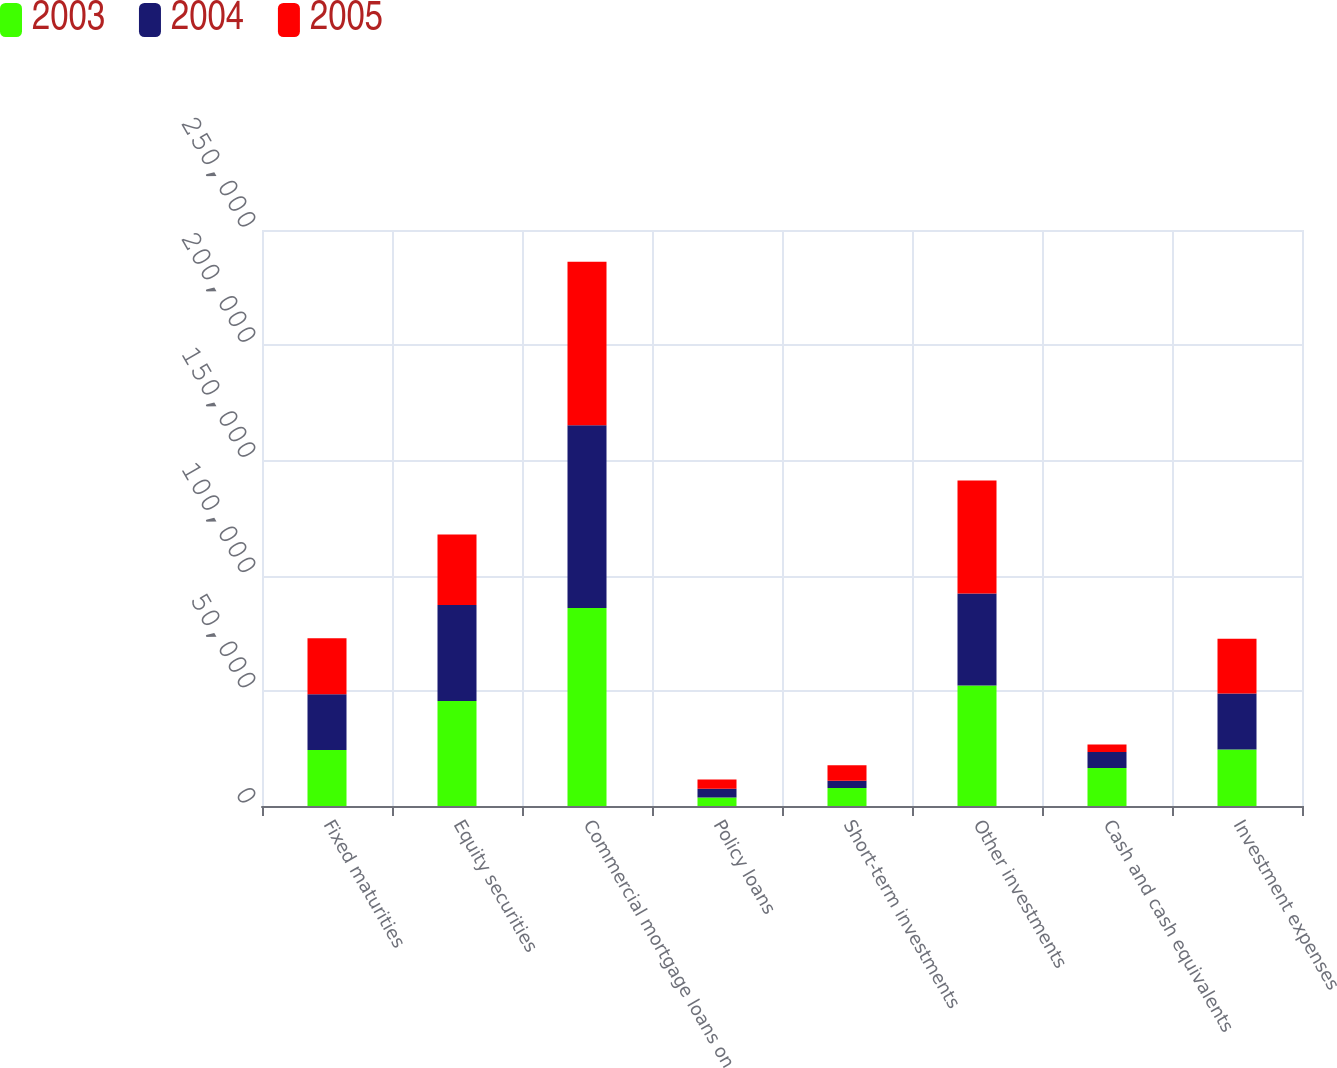<chart> <loc_0><loc_0><loc_500><loc_500><stacked_bar_chart><ecel><fcel>Fixed maturities<fcel>Equity securities<fcel>Commercial mortgage loans on<fcel>Policy loans<fcel>Short-term investments<fcel>Other investments<fcel>Cash and cash equivalents<fcel>Investment expenses<nl><fcel>2003<fcel>24268<fcel>45621<fcel>85942<fcel>3699<fcel>7774<fcel>52295<fcel>16542<fcel>24566<nl><fcel>2004<fcel>24268<fcel>41592<fcel>79334<fcel>3832<fcel>3158<fcel>39927<fcel>6942<fcel>24268<nl><fcel>2005<fcel>24268<fcel>30593<fcel>70988<fcel>3920<fcel>6758<fcel>49007<fcel>3158<fcel>23796<nl></chart> 